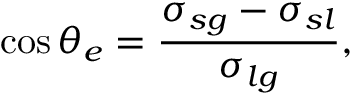Convert formula to latex. <formula><loc_0><loc_0><loc_500><loc_500>\cos \theta _ { e } = \frac { \sigma _ { s g } - \sigma _ { s l } } { \sigma _ { l g } } ,</formula> 